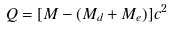<formula> <loc_0><loc_0><loc_500><loc_500>Q = [ M - ( M _ { d } + M _ { e } ) ] c ^ { 2 }</formula> 